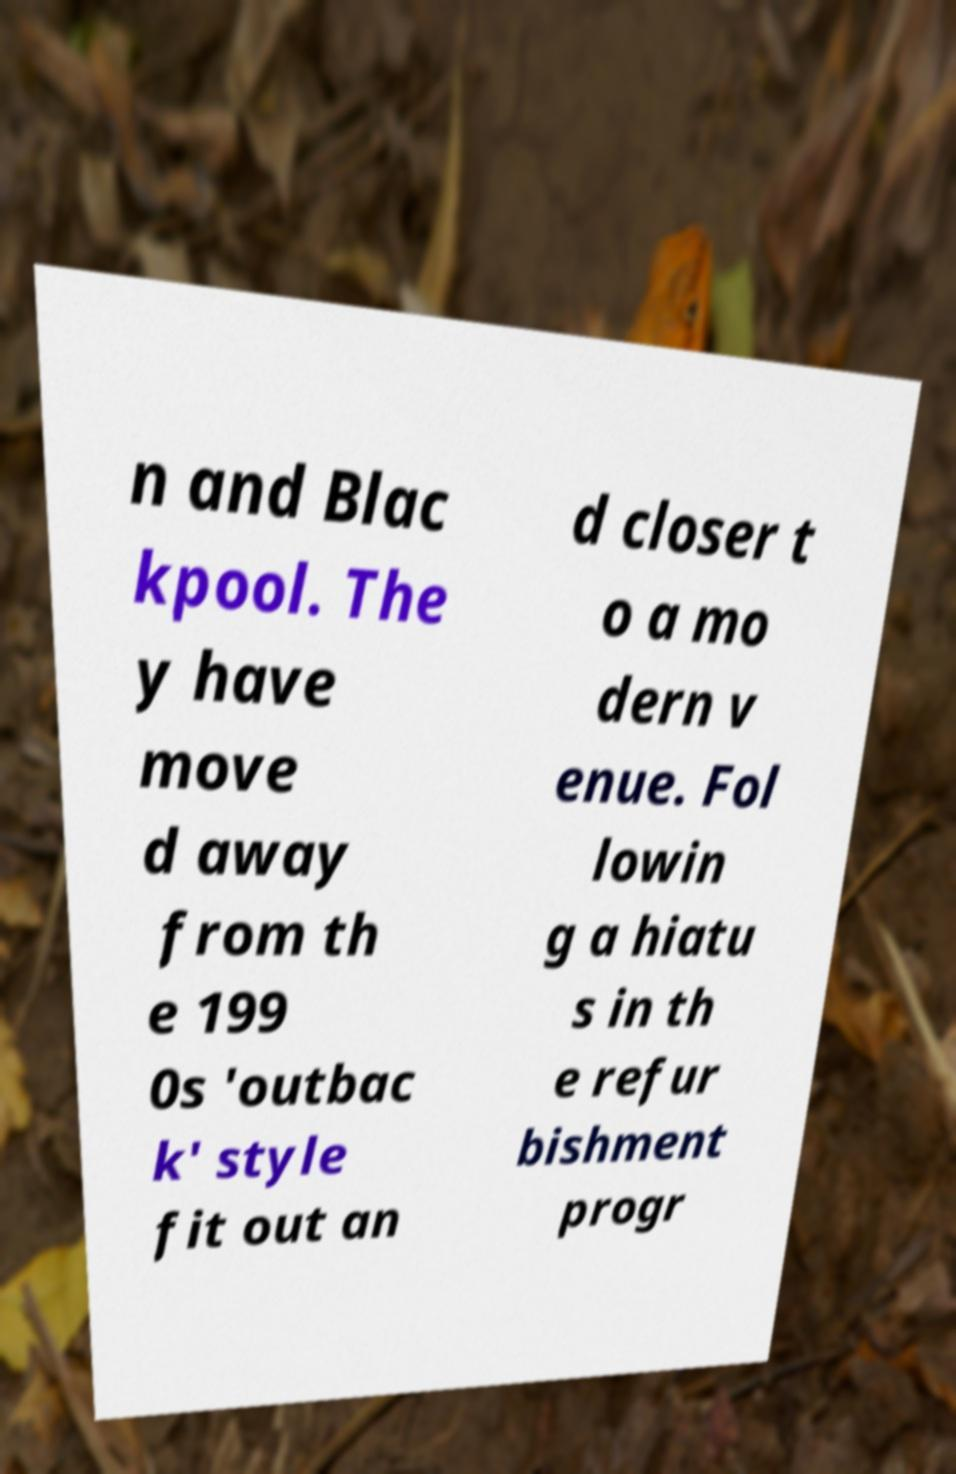Could you assist in decoding the text presented in this image and type it out clearly? n and Blac kpool. The y have move d away from th e 199 0s 'outbac k' style fit out an d closer t o a mo dern v enue. Fol lowin g a hiatu s in th e refur bishment progr 